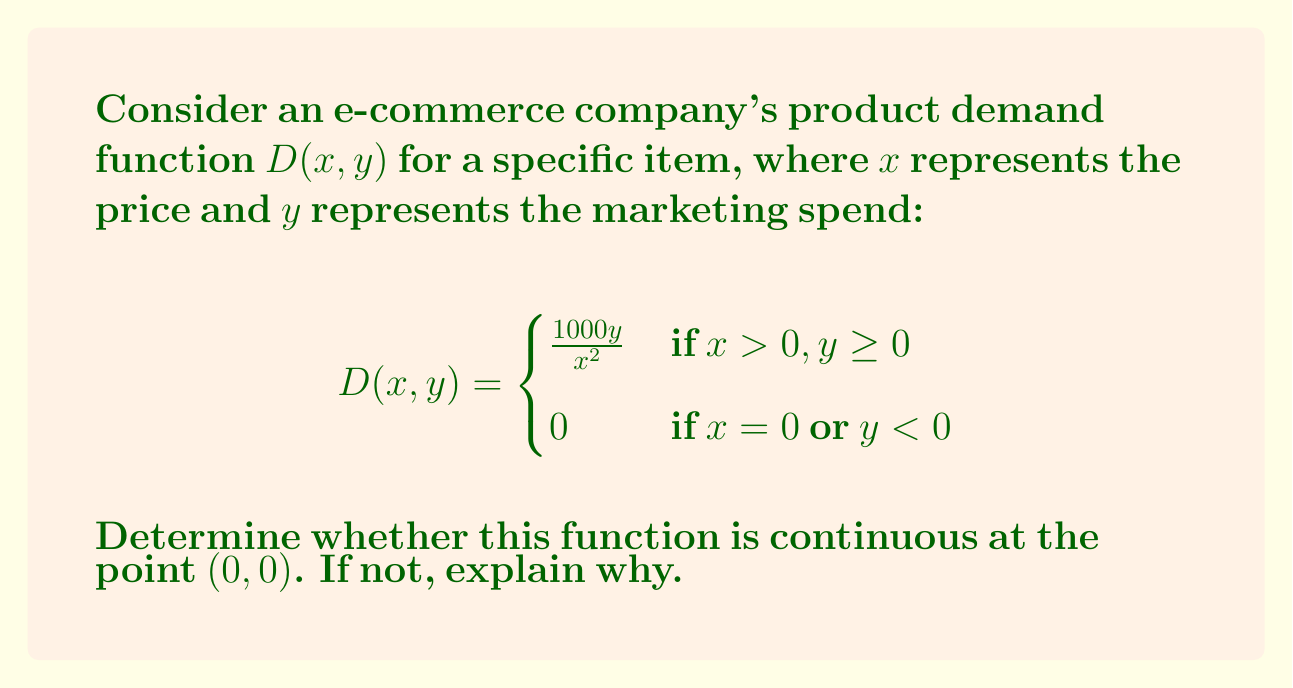Give your solution to this math problem. To determine the continuity of $D(x, y)$ at $(0, 0)$, we need to check if the following three conditions are met:

1. $D(0, 0)$ is defined
2. $\lim_{(x, y) \to (0, 0)} D(x, y)$ exists
3. $\lim_{(x, y) \to (0, 0)} D(x, y) = D(0, 0)$

Step 1: Check if $D(0, 0)$ is defined
From the piecewise definition, we can see that $D(0, 0) = 0$.

Step 2: Check if the limit exists
To check if the limit exists, we'll approach $(0, 0)$ from different paths:

Path 1: Along the x-axis (y = 0)
$$\lim_{x \to 0^+} D(x, 0) = \lim_{x \to 0^+} \frac{1000 \cdot 0}{x^2} = 0$$

Path 2: Along the line y = x²
$$\lim_{x \to 0^+} D(x, x^2) = \lim_{x \to 0^+} \frac{1000x^2}{x^2} = 1000$$

Since we get different limits along different paths, the limit does not exist.

Step 3: Compare the limit to the function value
Since the limit doesn't exist, we don't need to perform this step.

Conclusion: The function is not continuous at $(0, 0)$ because the limit does not exist as we approach this point from different directions. This discontinuity represents a sudden jump in product demand at the boundary between zero and positive prices, which is not realistic in practice and indicates a need for a more refined demand model.
Answer: Not continuous at $(0, 0)$ 